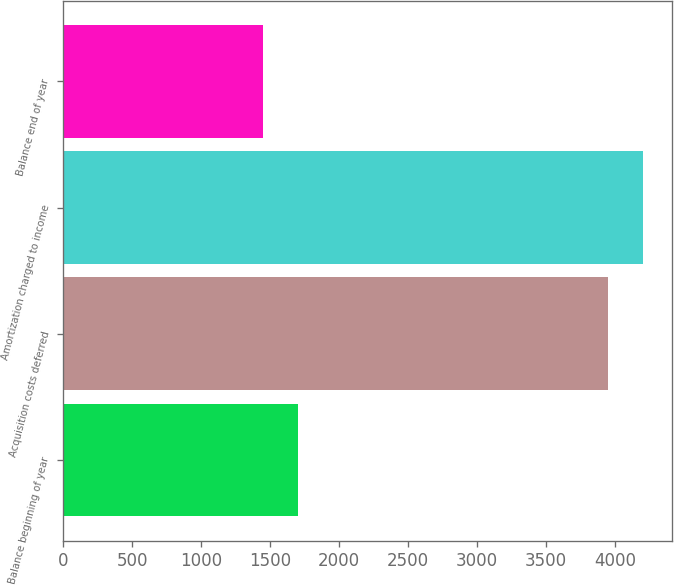Convert chart to OTSL. <chart><loc_0><loc_0><loc_500><loc_500><bar_chart><fcel>Balance beginning of year<fcel>Acquisition costs deferred<fcel>Amortization charged to income<fcel>Balance end of year<nl><fcel>1705.2<fcel>3951<fcel>4203.2<fcel>1453<nl></chart> 